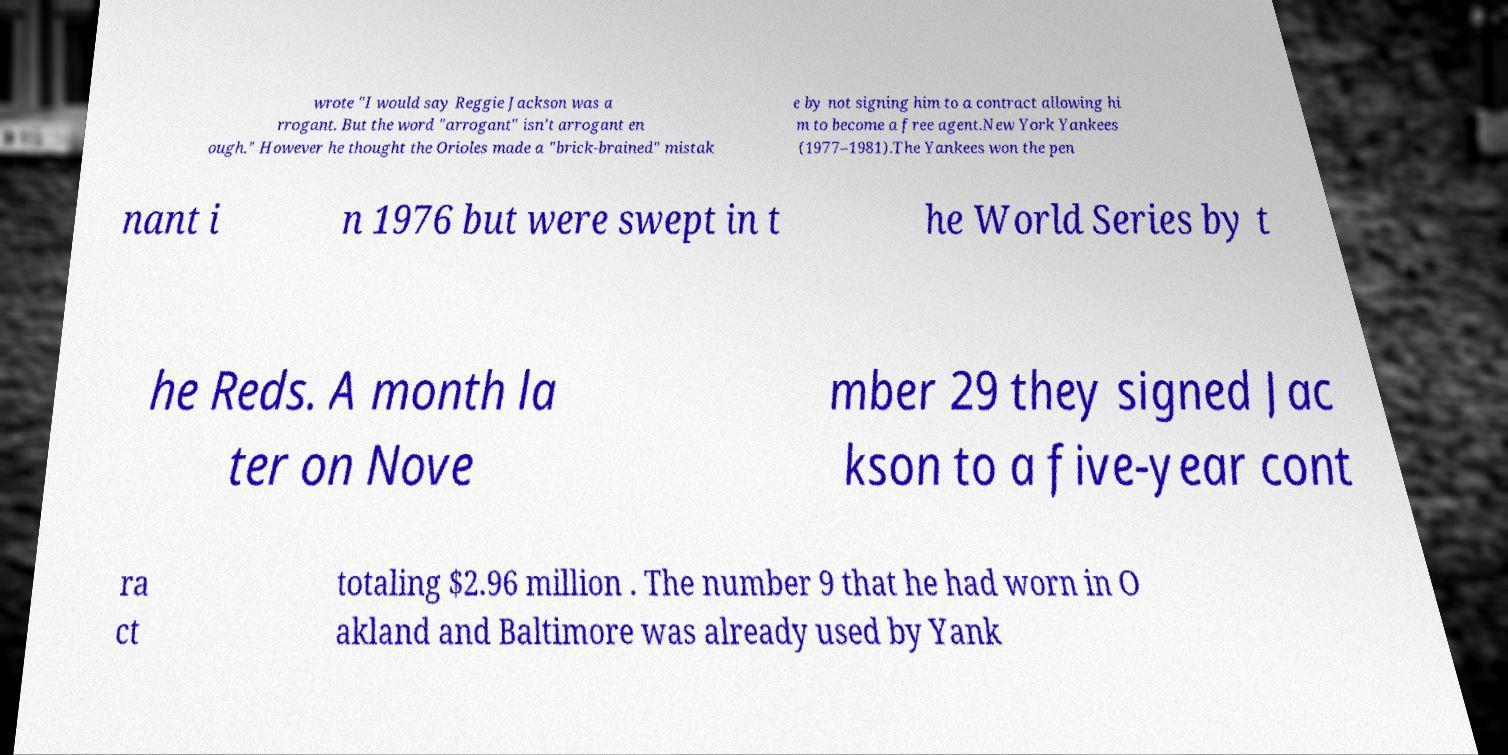Please identify and transcribe the text found in this image. wrote "I would say Reggie Jackson was a rrogant. But the word "arrogant" isn't arrogant en ough." However he thought the Orioles made a "brick-brained" mistak e by not signing him to a contract allowing hi m to become a free agent.New York Yankees (1977–1981).The Yankees won the pen nant i n 1976 but were swept in t he World Series by t he Reds. A month la ter on Nove mber 29 they signed Jac kson to a five-year cont ra ct totaling $2.96 million . The number 9 that he had worn in O akland and Baltimore was already used by Yank 